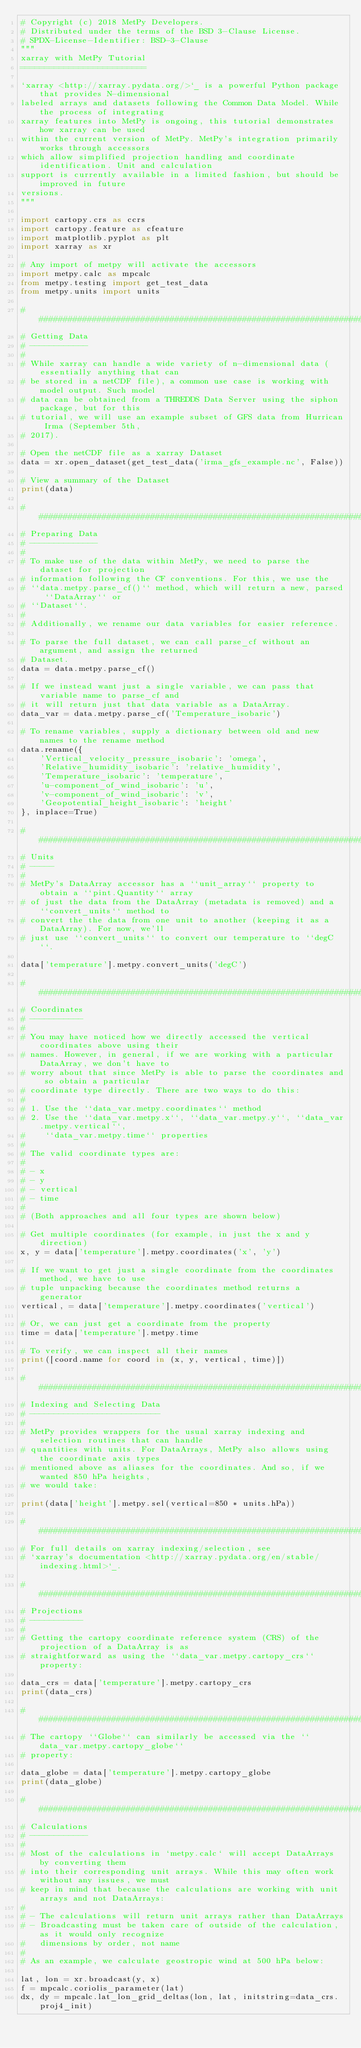<code> <loc_0><loc_0><loc_500><loc_500><_Python_># Copyright (c) 2018 MetPy Developers.
# Distributed under the terms of the BSD 3-Clause License.
# SPDX-License-Identifier: BSD-3-Clause
"""
xarray with MetPy Tutorial
==========================

`xarray <http://xarray.pydata.org/>`_ is a powerful Python package that provides N-dimensional
labeled arrays and datasets following the Common Data Model. While the process of integrating
xarray features into MetPy is ongoing, this tutorial demonstrates how xarray can be used
within the current version of MetPy. MetPy's integration primarily works through accessors
which allow simplified projection handling and coordinate identification. Unit and calculation
support is currently available in a limited fashion, but should be improved in future
versions.
"""

import cartopy.crs as ccrs
import cartopy.feature as cfeature
import matplotlib.pyplot as plt
import xarray as xr

# Any import of metpy will activate the accessors
import metpy.calc as mpcalc
from metpy.testing import get_test_data
from metpy.units import units

#########################################################################
# Getting Data
# ------------
#
# While xarray can handle a wide variety of n-dimensional data (essentially anything that can
# be stored in a netCDF file), a common use case is working with model output. Such model
# data can be obtained from a THREDDS Data Server using the siphon package, but for this
# tutorial, we will use an example subset of GFS data from Hurrican Irma (September 5th,
# 2017).

# Open the netCDF file as a xarray Dataset
data = xr.open_dataset(get_test_data('irma_gfs_example.nc', False))

# View a summary of the Dataset
print(data)

#########################################################################
# Preparing Data
# --------------
#
# To make use of the data within MetPy, we need to parse the dataset for projection
# information following the CF conventions. For this, we use the
# ``data.metpy.parse_cf()`` method, which will return a new, parsed ``DataArray`` or
# ``Dataset``.
#
# Additionally, we rename our data variables for easier reference.

# To parse the full dataset, we can call parse_cf without an argument, and assign the returned
# Dataset.
data = data.metpy.parse_cf()

# If we instead want just a single variable, we can pass that variable name to parse_cf and
# it will return just that data variable as a DataArray.
data_var = data.metpy.parse_cf('Temperature_isobaric')

# To rename variables, supply a dictionary between old and new names to the rename method
data.rename({
    'Vertical_velocity_pressure_isobaric': 'omega',
    'Relative_humidity_isobaric': 'relative_humidity',
    'Temperature_isobaric': 'temperature',
    'u-component_of_wind_isobaric': 'u',
    'v-component_of_wind_isobaric': 'v',
    'Geopotential_height_isobaric': 'height'
}, inplace=True)

#########################################################################
# Units
# -----
#
# MetPy's DataArray accessor has a ``unit_array`` property to obtain a ``pint.Quantity`` array
# of just the data from the DataArray (metadata is removed) and a ``convert_units`` method to
# convert the the data from one unit to another (keeping it as a DataArray). For now, we'll
# just use ``convert_units`` to convert our temperature to ``degC``.

data['temperature'].metpy.convert_units('degC')

#########################################################################
# Coordinates
# -----------
#
# You may have noticed how we directly accessed the vertical coordinates above using their
# names. However, in general, if we are working with a particular DataArray, we don't have to
# worry about that since MetPy is able to parse the coordinates and so obtain a particular
# coordinate type directly. There are two ways to do this:
#
# 1. Use the ``data_var.metpy.coordinates`` method
# 2. Use the ``data_var.metpy.x``, ``data_var.metpy.y``, ``data_var.metpy.vertical``,
#    ``data_var.metpy.time`` properties
#
# The valid coordinate types are:
#
# - x
# - y
# - vertical
# - time
#
# (Both approaches and all four types are shown below)

# Get multiple coordinates (for example, in just the x and y direction)
x, y = data['temperature'].metpy.coordinates('x', 'y')

# If we want to get just a single coordinate from the coordinates method, we have to use
# tuple unpacking because the coordinates method returns a generator
vertical, = data['temperature'].metpy.coordinates('vertical')

# Or, we can just get a coordinate from the property
time = data['temperature'].metpy.time

# To verify, we can inspect all their names
print([coord.name for coord in (x, y, vertical, time)])

#########################################################################
# Indexing and Selecting Data
# ---------------------------
#
# MetPy provides wrappers for the usual xarray indexing and selection routines that can handle
# quantities with units. For DataArrays, MetPy also allows using the coordinate axis types
# mentioned above as aliases for the coordinates. And so, if we wanted 850 hPa heights,
# we would take:

print(data['height'].metpy.sel(vertical=850 * units.hPa))

#########################################################################
# For full details on xarray indexing/selection, see
# `xarray's documentation <http://xarray.pydata.org/en/stable/indexing.html>`_.

#########################################################################
# Projections
# -----------
#
# Getting the cartopy coordinate reference system (CRS) of the projection of a DataArray is as
# straightforward as using the ``data_var.metpy.cartopy_crs`` property:

data_crs = data['temperature'].metpy.cartopy_crs
print(data_crs)

#########################################################################
# The cartopy ``Globe`` can similarly be accessed via the ``data_var.metpy.cartopy_globe``
# property:

data_globe = data['temperature'].metpy.cartopy_globe
print(data_globe)

#########################################################################
# Calculations
# ------------
#
# Most of the calculations in `metpy.calc` will accept DataArrays by converting them
# into their corresponding unit arrays. While this may often work without any issues, we must
# keep in mind that because the calculations are working with unit arrays and not DataArrays:
#
# - The calculations will return unit arrays rather than DataArrays
# - Broadcasting must be taken care of outside of the calculation, as it would only recognize
#   dimensions by order, not name
#
# As an example, we calculate geostropic wind at 500 hPa below:

lat, lon = xr.broadcast(y, x)
f = mpcalc.coriolis_parameter(lat)
dx, dy = mpcalc.lat_lon_grid_deltas(lon, lat, initstring=data_crs.proj4_init)</code> 